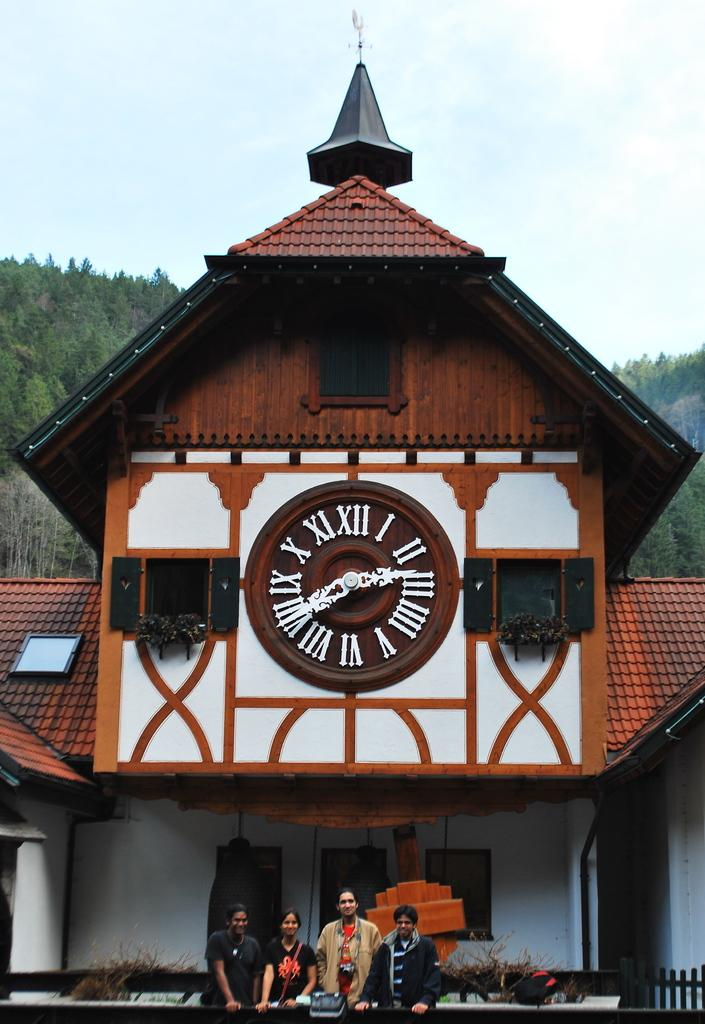<image>
Share a concise interpretation of the image provided. According to the large clock on the front of a building, the time is approximately 2:40. 